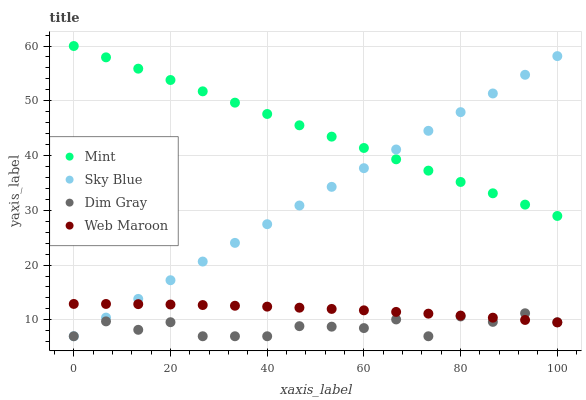Does Dim Gray have the minimum area under the curve?
Answer yes or no. Yes. Does Mint have the maximum area under the curve?
Answer yes or no. Yes. Does Mint have the minimum area under the curve?
Answer yes or no. No. Does Dim Gray have the maximum area under the curve?
Answer yes or no. No. Is Sky Blue the smoothest?
Answer yes or no. Yes. Is Dim Gray the roughest?
Answer yes or no. Yes. Is Mint the smoothest?
Answer yes or no. No. Is Mint the roughest?
Answer yes or no. No. Does Sky Blue have the lowest value?
Answer yes or no. Yes. Does Mint have the lowest value?
Answer yes or no. No. Does Mint have the highest value?
Answer yes or no. Yes. Does Dim Gray have the highest value?
Answer yes or no. No. Is Dim Gray less than Mint?
Answer yes or no. Yes. Is Mint greater than Dim Gray?
Answer yes or no. Yes. Does Web Maroon intersect Sky Blue?
Answer yes or no. Yes. Is Web Maroon less than Sky Blue?
Answer yes or no. No. Is Web Maroon greater than Sky Blue?
Answer yes or no. No. Does Dim Gray intersect Mint?
Answer yes or no. No. 